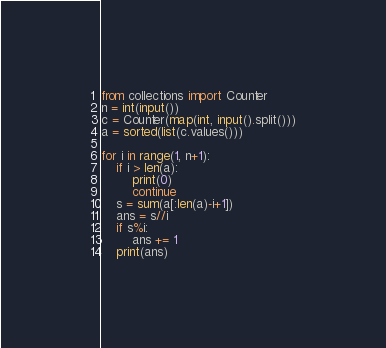Convert code to text. <code><loc_0><loc_0><loc_500><loc_500><_Python_>from collections import Counter
n = int(input())
c = Counter(map(int, input().split()))
a = sorted(list(c.values()))

for i in range(1, n+1):
    if i > len(a):
        print(0)
        continue
    s = sum(a[:len(a)-i+1])
    ans = s//i
    if s%i:
        ans += 1
    print(ans)</code> 